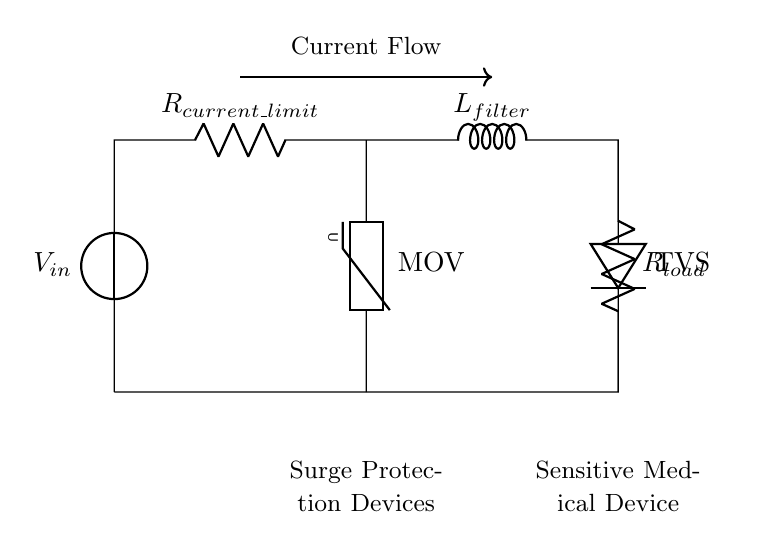What is the input voltage in this circuit? The input voltage is labeled as V_in in the circuit diagram, which represents the source voltage supplied to the circuit.
Answer: V_in What type of surge protection device is present? The circuit diagram includes a Metal Oxide Varistor, abbreviated as MOV, which is used for transient voltage suppression and protecting against voltage spikes.
Answer: MOV How many resistors are in the circuit? There are two resistors clearly labeled in the circuit: R_current_limit and R_load, which are used for current limiting and load functions, respectively.
Answer: 2 What is the purpose of the inductor in the circuit? The inductor labeled L_filter is used to filter out voltage spikes and smoothen the current flow, which helps protect the sensitive medical device.
Answer: Filtering What components are used for surge protection in this circuit? The circuit shows both a MOV and a TVS diode, which together act as surge protection devices by clamping excess voltage to protect downstream components.
Answer: MOV and TVS What is the configuration type of the circuit? The circuit is designed in a series configuration, meaning all components are connected end-to-end in a single path for current to flow.
Answer: Series 